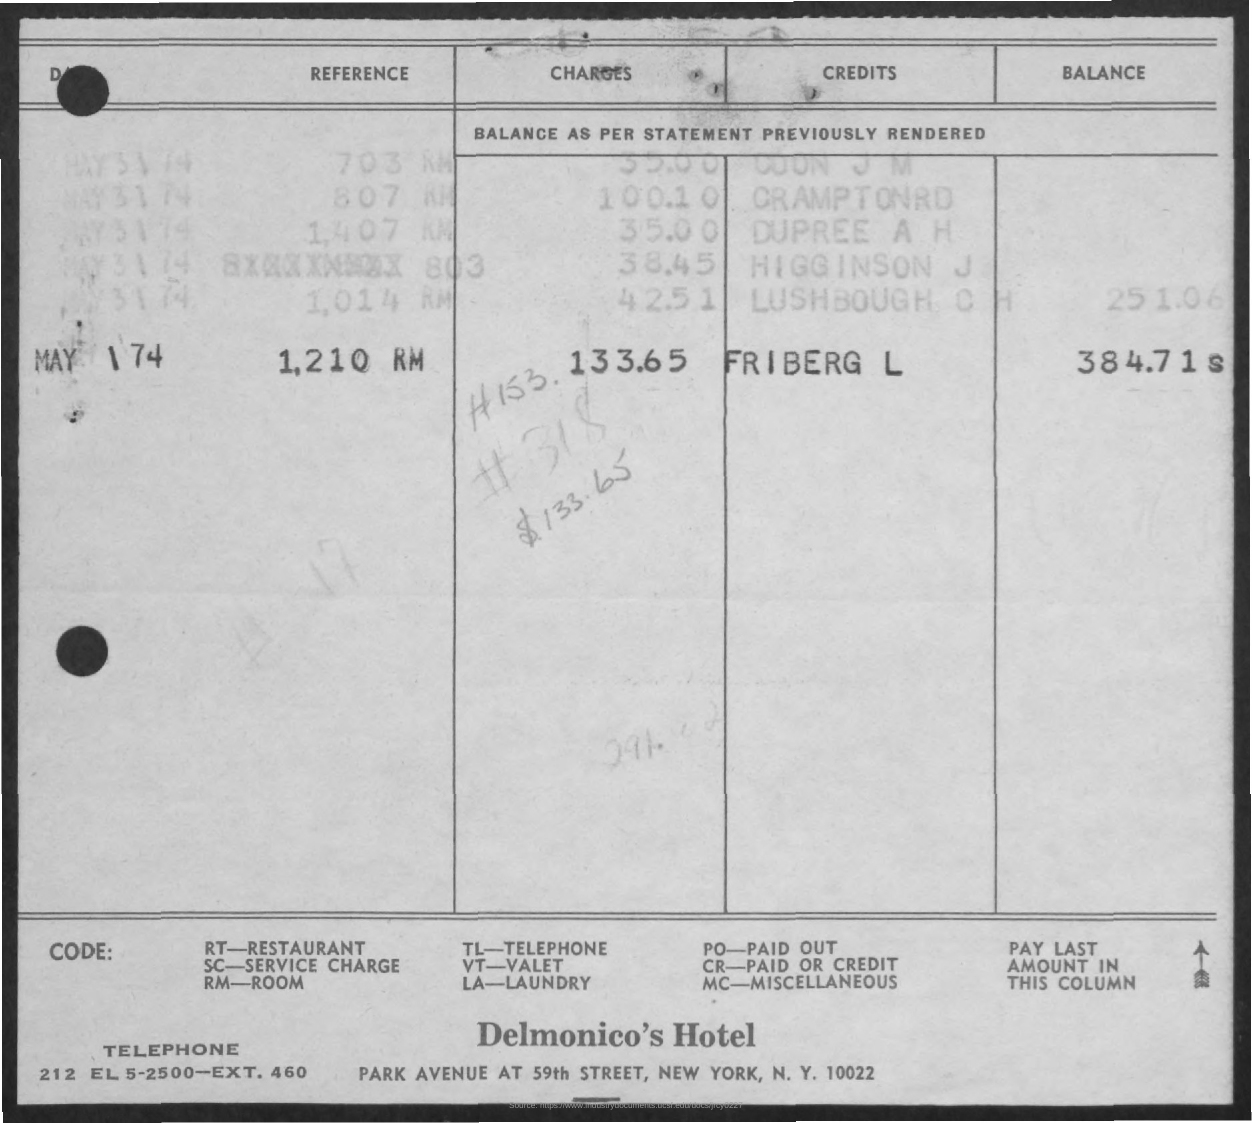What is the name of the hotel?
Give a very brief answer. Delmonico's Hotel. What is the full form of TL?
Make the answer very short. Telephone. What is the full form of RT?
Keep it short and to the point. Restaurant. What is the full form of RM?
Provide a short and direct response. Room. 